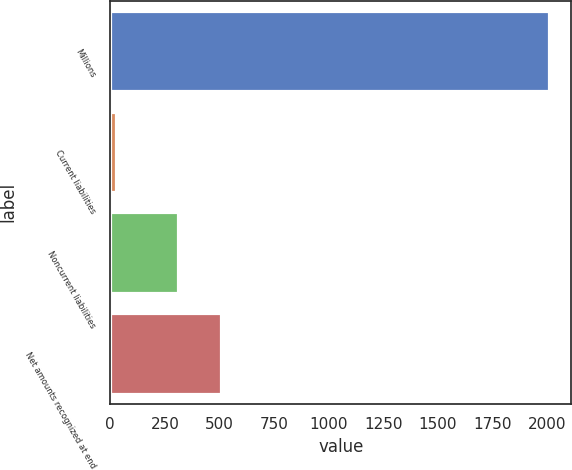<chart> <loc_0><loc_0><loc_500><loc_500><bar_chart><fcel>Millions<fcel>Current liabilities<fcel>Noncurrent liabilities<fcel>Net amounts recognized at end<nl><fcel>2011<fcel>26<fcel>310<fcel>508.5<nl></chart> 